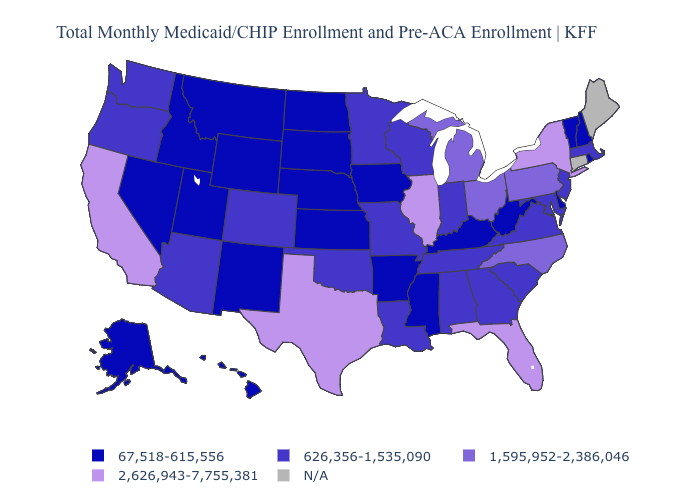What is the value of South Dakota?
Give a very brief answer. 67,518-615,556. What is the highest value in the USA?
Keep it brief. 2,626,943-7,755,381. What is the value of North Dakota?
Concise answer only. 67,518-615,556. What is the value of Georgia?
Keep it brief. 626,356-1,535,090. What is the highest value in the USA?
Keep it brief. 2,626,943-7,755,381. Does Vermont have the lowest value in the Northeast?
Be succinct. Yes. Which states have the highest value in the USA?
Short answer required. California, Florida, Illinois, New York, Texas. Does Idaho have the lowest value in the USA?
Be succinct. Yes. Does Delaware have the lowest value in the USA?
Keep it brief. Yes. What is the value of Washington?
Be succinct. 626,356-1,535,090. What is the value of New York?
Write a very short answer. 2,626,943-7,755,381. Among the states that border Virginia , which have the highest value?
Keep it brief. North Carolina. What is the value of Arizona?
Short answer required. 626,356-1,535,090. What is the lowest value in the MidWest?
Keep it brief. 67,518-615,556. 